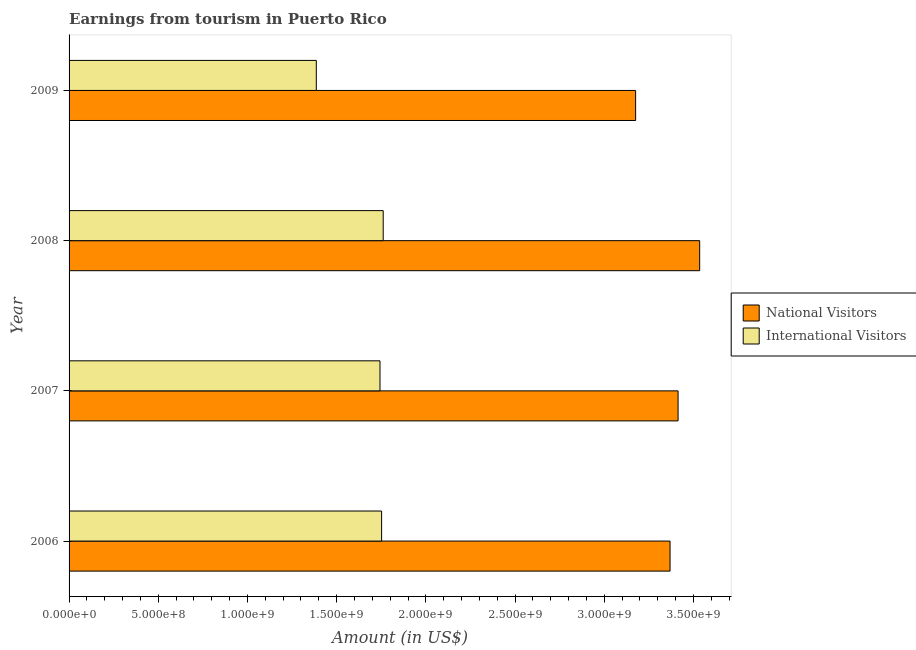How many bars are there on the 4th tick from the top?
Make the answer very short. 2. In how many cases, is the number of bars for a given year not equal to the number of legend labels?
Your answer should be very brief. 0. What is the amount earned from national visitors in 2008?
Give a very brief answer. 3.54e+09. Across all years, what is the maximum amount earned from international visitors?
Offer a very short reply. 1.76e+09. Across all years, what is the minimum amount earned from national visitors?
Your answer should be compact. 3.18e+09. In which year was the amount earned from international visitors maximum?
Give a very brief answer. 2008. In which year was the amount earned from national visitors minimum?
Your answer should be compact. 2009. What is the total amount earned from international visitors in the graph?
Your response must be concise. 6.64e+09. What is the difference between the amount earned from national visitors in 2007 and that in 2009?
Provide a short and direct response. 2.38e+08. What is the difference between the amount earned from international visitors in 2006 and the amount earned from national visitors in 2008?
Provide a succinct answer. -1.78e+09. What is the average amount earned from international visitors per year?
Ensure brevity in your answer.  1.66e+09. In the year 2008, what is the difference between the amount earned from national visitors and amount earned from international visitors?
Your response must be concise. 1.77e+09. In how many years, is the amount earned from national visitors greater than 700000000 US$?
Give a very brief answer. 4. What is the ratio of the amount earned from national visitors in 2006 to that in 2007?
Your answer should be very brief. 0.99. Is the amount earned from national visitors in 2006 less than that in 2008?
Your response must be concise. Yes. What is the difference between the highest and the second highest amount earned from national visitors?
Make the answer very short. 1.21e+08. What is the difference between the highest and the lowest amount earned from national visitors?
Offer a very short reply. 3.59e+08. What does the 2nd bar from the top in 2007 represents?
Provide a succinct answer. National Visitors. What does the 1st bar from the bottom in 2009 represents?
Ensure brevity in your answer.  National Visitors. How many bars are there?
Provide a succinct answer. 8. Are all the bars in the graph horizontal?
Provide a succinct answer. Yes. Are the values on the major ticks of X-axis written in scientific E-notation?
Your answer should be compact. Yes. Does the graph contain grids?
Keep it short and to the point. No. Where does the legend appear in the graph?
Offer a very short reply. Center right. How many legend labels are there?
Provide a short and direct response. 2. How are the legend labels stacked?
Keep it short and to the point. Vertical. What is the title of the graph?
Give a very brief answer. Earnings from tourism in Puerto Rico. What is the label or title of the X-axis?
Your answer should be compact. Amount (in US$). What is the label or title of the Y-axis?
Give a very brief answer. Year. What is the Amount (in US$) of National Visitors in 2006?
Ensure brevity in your answer.  3.37e+09. What is the Amount (in US$) of International Visitors in 2006?
Ensure brevity in your answer.  1.75e+09. What is the Amount (in US$) in National Visitors in 2007?
Make the answer very short. 3.41e+09. What is the Amount (in US$) of International Visitors in 2007?
Your response must be concise. 1.74e+09. What is the Amount (in US$) of National Visitors in 2008?
Offer a terse response. 3.54e+09. What is the Amount (in US$) in International Visitors in 2008?
Your response must be concise. 1.76e+09. What is the Amount (in US$) of National Visitors in 2009?
Your answer should be compact. 3.18e+09. What is the Amount (in US$) in International Visitors in 2009?
Make the answer very short. 1.39e+09. Across all years, what is the maximum Amount (in US$) in National Visitors?
Offer a terse response. 3.54e+09. Across all years, what is the maximum Amount (in US$) of International Visitors?
Provide a short and direct response. 1.76e+09. Across all years, what is the minimum Amount (in US$) in National Visitors?
Keep it short and to the point. 3.18e+09. Across all years, what is the minimum Amount (in US$) in International Visitors?
Offer a very short reply. 1.39e+09. What is the total Amount (in US$) in National Visitors in the graph?
Your response must be concise. 1.35e+1. What is the total Amount (in US$) of International Visitors in the graph?
Provide a short and direct response. 6.64e+09. What is the difference between the Amount (in US$) of National Visitors in 2006 and that in 2007?
Keep it short and to the point. -4.50e+07. What is the difference between the Amount (in US$) of International Visitors in 2006 and that in 2007?
Offer a terse response. 9.00e+06. What is the difference between the Amount (in US$) of National Visitors in 2006 and that in 2008?
Your answer should be compact. -1.66e+08. What is the difference between the Amount (in US$) of International Visitors in 2006 and that in 2008?
Provide a short and direct response. -9.00e+06. What is the difference between the Amount (in US$) of National Visitors in 2006 and that in 2009?
Make the answer very short. 1.93e+08. What is the difference between the Amount (in US$) of International Visitors in 2006 and that in 2009?
Your response must be concise. 3.66e+08. What is the difference between the Amount (in US$) in National Visitors in 2007 and that in 2008?
Offer a terse response. -1.21e+08. What is the difference between the Amount (in US$) in International Visitors in 2007 and that in 2008?
Your response must be concise. -1.80e+07. What is the difference between the Amount (in US$) of National Visitors in 2007 and that in 2009?
Keep it short and to the point. 2.38e+08. What is the difference between the Amount (in US$) of International Visitors in 2007 and that in 2009?
Your response must be concise. 3.57e+08. What is the difference between the Amount (in US$) of National Visitors in 2008 and that in 2009?
Your answer should be compact. 3.59e+08. What is the difference between the Amount (in US$) of International Visitors in 2008 and that in 2009?
Offer a very short reply. 3.75e+08. What is the difference between the Amount (in US$) of National Visitors in 2006 and the Amount (in US$) of International Visitors in 2007?
Offer a terse response. 1.63e+09. What is the difference between the Amount (in US$) in National Visitors in 2006 and the Amount (in US$) in International Visitors in 2008?
Offer a very short reply. 1.61e+09. What is the difference between the Amount (in US$) in National Visitors in 2006 and the Amount (in US$) in International Visitors in 2009?
Provide a short and direct response. 1.98e+09. What is the difference between the Amount (in US$) in National Visitors in 2007 and the Amount (in US$) in International Visitors in 2008?
Offer a terse response. 1.65e+09. What is the difference between the Amount (in US$) in National Visitors in 2007 and the Amount (in US$) in International Visitors in 2009?
Offer a very short reply. 2.03e+09. What is the difference between the Amount (in US$) in National Visitors in 2008 and the Amount (in US$) in International Visitors in 2009?
Your answer should be very brief. 2.15e+09. What is the average Amount (in US$) in National Visitors per year?
Your answer should be very brief. 3.37e+09. What is the average Amount (in US$) of International Visitors per year?
Keep it short and to the point. 1.66e+09. In the year 2006, what is the difference between the Amount (in US$) in National Visitors and Amount (in US$) in International Visitors?
Provide a short and direct response. 1.62e+09. In the year 2007, what is the difference between the Amount (in US$) of National Visitors and Amount (in US$) of International Visitors?
Offer a very short reply. 1.67e+09. In the year 2008, what is the difference between the Amount (in US$) of National Visitors and Amount (in US$) of International Visitors?
Your response must be concise. 1.77e+09. In the year 2009, what is the difference between the Amount (in US$) in National Visitors and Amount (in US$) in International Visitors?
Make the answer very short. 1.79e+09. What is the ratio of the Amount (in US$) of International Visitors in 2006 to that in 2007?
Give a very brief answer. 1.01. What is the ratio of the Amount (in US$) of National Visitors in 2006 to that in 2008?
Keep it short and to the point. 0.95. What is the ratio of the Amount (in US$) of International Visitors in 2006 to that in 2008?
Your response must be concise. 0.99. What is the ratio of the Amount (in US$) in National Visitors in 2006 to that in 2009?
Provide a short and direct response. 1.06. What is the ratio of the Amount (in US$) of International Visitors in 2006 to that in 2009?
Provide a succinct answer. 1.26. What is the ratio of the Amount (in US$) in National Visitors in 2007 to that in 2008?
Keep it short and to the point. 0.97. What is the ratio of the Amount (in US$) of National Visitors in 2007 to that in 2009?
Ensure brevity in your answer.  1.07. What is the ratio of the Amount (in US$) of International Visitors in 2007 to that in 2009?
Offer a terse response. 1.26. What is the ratio of the Amount (in US$) of National Visitors in 2008 to that in 2009?
Make the answer very short. 1.11. What is the ratio of the Amount (in US$) in International Visitors in 2008 to that in 2009?
Your response must be concise. 1.27. What is the difference between the highest and the second highest Amount (in US$) of National Visitors?
Provide a succinct answer. 1.21e+08. What is the difference between the highest and the second highest Amount (in US$) in International Visitors?
Offer a very short reply. 9.00e+06. What is the difference between the highest and the lowest Amount (in US$) of National Visitors?
Offer a very short reply. 3.59e+08. What is the difference between the highest and the lowest Amount (in US$) of International Visitors?
Provide a short and direct response. 3.75e+08. 